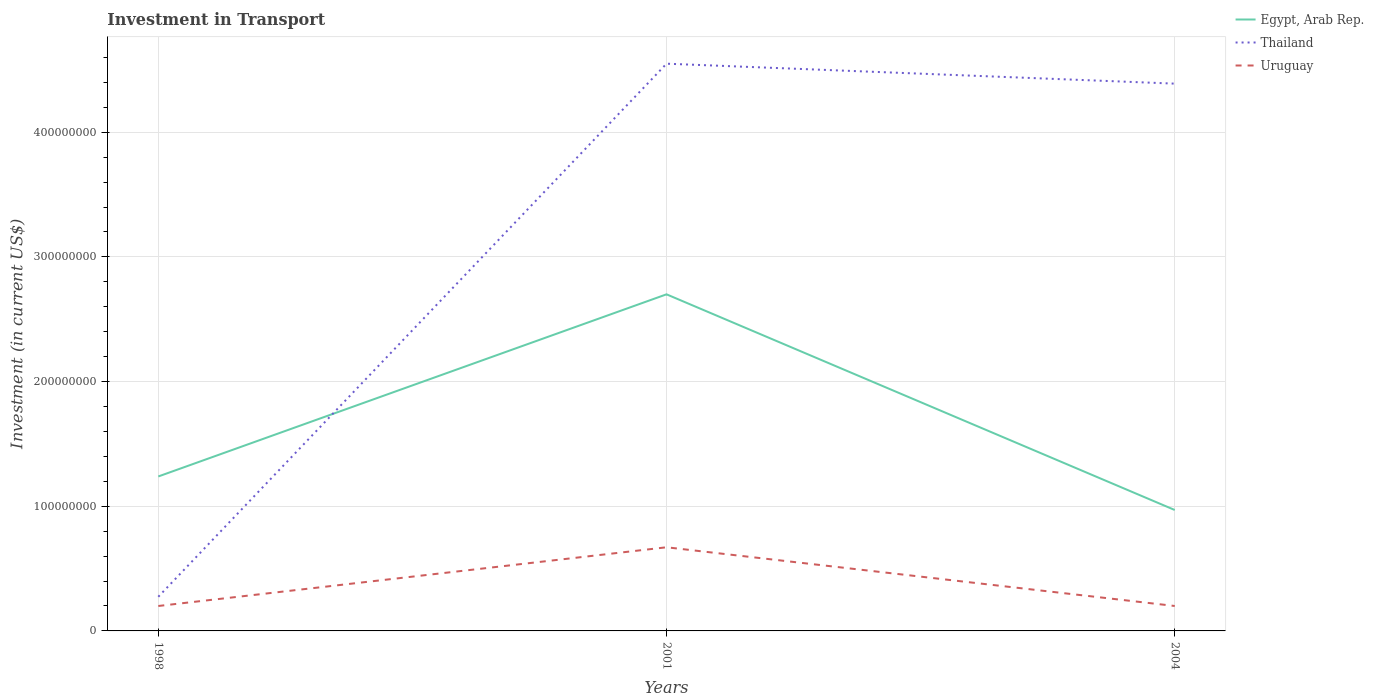Across all years, what is the maximum amount invested in transport in Thailand?
Give a very brief answer. 2.74e+07. What is the total amount invested in transport in Thailand in the graph?
Ensure brevity in your answer.  1.60e+07. What is the difference between the highest and the second highest amount invested in transport in Egypt, Arab Rep.?
Your answer should be very brief. 1.73e+08. What is the difference between the highest and the lowest amount invested in transport in Thailand?
Make the answer very short. 2. Is the amount invested in transport in Uruguay strictly greater than the amount invested in transport in Egypt, Arab Rep. over the years?
Make the answer very short. Yes. How many years are there in the graph?
Your answer should be very brief. 3. What is the difference between two consecutive major ticks on the Y-axis?
Make the answer very short. 1.00e+08. Does the graph contain any zero values?
Offer a very short reply. No. Does the graph contain grids?
Your answer should be compact. Yes. Where does the legend appear in the graph?
Your answer should be very brief. Top right. How many legend labels are there?
Give a very brief answer. 3. What is the title of the graph?
Offer a terse response. Investment in Transport. What is the label or title of the Y-axis?
Provide a succinct answer. Investment (in current US$). What is the Investment (in current US$) of Egypt, Arab Rep. in 1998?
Your answer should be compact. 1.24e+08. What is the Investment (in current US$) of Thailand in 1998?
Offer a very short reply. 2.74e+07. What is the Investment (in current US$) in Uruguay in 1998?
Offer a terse response. 2.00e+07. What is the Investment (in current US$) of Egypt, Arab Rep. in 2001?
Provide a succinct answer. 2.70e+08. What is the Investment (in current US$) of Thailand in 2001?
Your response must be concise. 4.55e+08. What is the Investment (in current US$) in Uruguay in 2001?
Provide a succinct answer. 6.71e+07. What is the Investment (in current US$) in Egypt, Arab Rep. in 2004?
Make the answer very short. 9.70e+07. What is the Investment (in current US$) in Thailand in 2004?
Provide a short and direct response. 4.39e+08. What is the Investment (in current US$) of Uruguay in 2004?
Your answer should be compact. 2.00e+07. Across all years, what is the maximum Investment (in current US$) in Egypt, Arab Rep.?
Your answer should be compact. 2.70e+08. Across all years, what is the maximum Investment (in current US$) of Thailand?
Offer a very short reply. 4.55e+08. Across all years, what is the maximum Investment (in current US$) of Uruguay?
Offer a very short reply. 6.71e+07. Across all years, what is the minimum Investment (in current US$) of Egypt, Arab Rep.?
Your answer should be compact. 9.70e+07. Across all years, what is the minimum Investment (in current US$) of Thailand?
Your response must be concise. 2.74e+07. What is the total Investment (in current US$) of Egypt, Arab Rep. in the graph?
Make the answer very short. 4.91e+08. What is the total Investment (in current US$) of Thailand in the graph?
Provide a succinct answer. 9.21e+08. What is the total Investment (in current US$) in Uruguay in the graph?
Your answer should be very brief. 1.07e+08. What is the difference between the Investment (in current US$) in Egypt, Arab Rep. in 1998 and that in 2001?
Offer a very short reply. -1.46e+08. What is the difference between the Investment (in current US$) in Thailand in 1998 and that in 2001?
Provide a short and direct response. -4.28e+08. What is the difference between the Investment (in current US$) of Uruguay in 1998 and that in 2001?
Your response must be concise. -4.71e+07. What is the difference between the Investment (in current US$) of Egypt, Arab Rep. in 1998 and that in 2004?
Keep it short and to the point. 2.69e+07. What is the difference between the Investment (in current US$) of Thailand in 1998 and that in 2004?
Make the answer very short. -4.12e+08. What is the difference between the Investment (in current US$) in Uruguay in 1998 and that in 2004?
Offer a very short reply. 0. What is the difference between the Investment (in current US$) of Egypt, Arab Rep. in 2001 and that in 2004?
Provide a short and direct response. 1.73e+08. What is the difference between the Investment (in current US$) in Thailand in 2001 and that in 2004?
Offer a very short reply. 1.60e+07. What is the difference between the Investment (in current US$) of Uruguay in 2001 and that in 2004?
Your answer should be compact. 4.71e+07. What is the difference between the Investment (in current US$) in Egypt, Arab Rep. in 1998 and the Investment (in current US$) in Thailand in 2001?
Provide a short and direct response. -3.31e+08. What is the difference between the Investment (in current US$) of Egypt, Arab Rep. in 1998 and the Investment (in current US$) of Uruguay in 2001?
Provide a short and direct response. 5.68e+07. What is the difference between the Investment (in current US$) of Thailand in 1998 and the Investment (in current US$) of Uruguay in 2001?
Your answer should be compact. -3.97e+07. What is the difference between the Investment (in current US$) of Egypt, Arab Rep. in 1998 and the Investment (in current US$) of Thailand in 2004?
Ensure brevity in your answer.  -3.15e+08. What is the difference between the Investment (in current US$) of Egypt, Arab Rep. in 1998 and the Investment (in current US$) of Uruguay in 2004?
Provide a short and direct response. 1.04e+08. What is the difference between the Investment (in current US$) of Thailand in 1998 and the Investment (in current US$) of Uruguay in 2004?
Offer a terse response. 7.40e+06. What is the difference between the Investment (in current US$) of Egypt, Arab Rep. in 2001 and the Investment (in current US$) of Thailand in 2004?
Offer a very short reply. -1.69e+08. What is the difference between the Investment (in current US$) of Egypt, Arab Rep. in 2001 and the Investment (in current US$) of Uruguay in 2004?
Give a very brief answer. 2.50e+08. What is the difference between the Investment (in current US$) in Thailand in 2001 and the Investment (in current US$) in Uruguay in 2004?
Provide a succinct answer. 4.35e+08. What is the average Investment (in current US$) of Egypt, Arab Rep. per year?
Keep it short and to the point. 1.64e+08. What is the average Investment (in current US$) of Thailand per year?
Offer a terse response. 3.07e+08. What is the average Investment (in current US$) in Uruguay per year?
Give a very brief answer. 3.57e+07. In the year 1998, what is the difference between the Investment (in current US$) of Egypt, Arab Rep. and Investment (in current US$) of Thailand?
Provide a succinct answer. 9.65e+07. In the year 1998, what is the difference between the Investment (in current US$) of Egypt, Arab Rep. and Investment (in current US$) of Uruguay?
Make the answer very short. 1.04e+08. In the year 1998, what is the difference between the Investment (in current US$) of Thailand and Investment (in current US$) of Uruguay?
Keep it short and to the point. 7.40e+06. In the year 2001, what is the difference between the Investment (in current US$) of Egypt, Arab Rep. and Investment (in current US$) of Thailand?
Your answer should be very brief. -1.85e+08. In the year 2001, what is the difference between the Investment (in current US$) in Egypt, Arab Rep. and Investment (in current US$) in Uruguay?
Offer a very short reply. 2.03e+08. In the year 2001, what is the difference between the Investment (in current US$) in Thailand and Investment (in current US$) in Uruguay?
Ensure brevity in your answer.  3.88e+08. In the year 2004, what is the difference between the Investment (in current US$) of Egypt, Arab Rep. and Investment (in current US$) of Thailand?
Offer a very short reply. -3.42e+08. In the year 2004, what is the difference between the Investment (in current US$) in Egypt, Arab Rep. and Investment (in current US$) in Uruguay?
Offer a terse response. 7.70e+07. In the year 2004, what is the difference between the Investment (in current US$) of Thailand and Investment (in current US$) of Uruguay?
Ensure brevity in your answer.  4.19e+08. What is the ratio of the Investment (in current US$) in Egypt, Arab Rep. in 1998 to that in 2001?
Make the answer very short. 0.46. What is the ratio of the Investment (in current US$) of Thailand in 1998 to that in 2001?
Your response must be concise. 0.06. What is the ratio of the Investment (in current US$) of Uruguay in 1998 to that in 2001?
Your answer should be very brief. 0.3. What is the ratio of the Investment (in current US$) of Egypt, Arab Rep. in 1998 to that in 2004?
Offer a very short reply. 1.28. What is the ratio of the Investment (in current US$) of Thailand in 1998 to that in 2004?
Make the answer very short. 0.06. What is the ratio of the Investment (in current US$) of Uruguay in 1998 to that in 2004?
Keep it short and to the point. 1. What is the ratio of the Investment (in current US$) of Egypt, Arab Rep. in 2001 to that in 2004?
Provide a succinct answer. 2.78. What is the ratio of the Investment (in current US$) of Thailand in 2001 to that in 2004?
Make the answer very short. 1.04. What is the ratio of the Investment (in current US$) in Uruguay in 2001 to that in 2004?
Keep it short and to the point. 3.35. What is the difference between the highest and the second highest Investment (in current US$) in Egypt, Arab Rep.?
Give a very brief answer. 1.46e+08. What is the difference between the highest and the second highest Investment (in current US$) in Thailand?
Keep it short and to the point. 1.60e+07. What is the difference between the highest and the second highest Investment (in current US$) of Uruguay?
Make the answer very short. 4.71e+07. What is the difference between the highest and the lowest Investment (in current US$) of Egypt, Arab Rep.?
Offer a terse response. 1.73e+08. What is the difference between the highest and the lowest Investment (in current US$) of Thailand?
Provide a succinct answer. 4.28e+08. What is the difference between the highest and the lowest Investment (in current US$) in Uruguay?
Your answer should be very brief. 4.71e+07. 